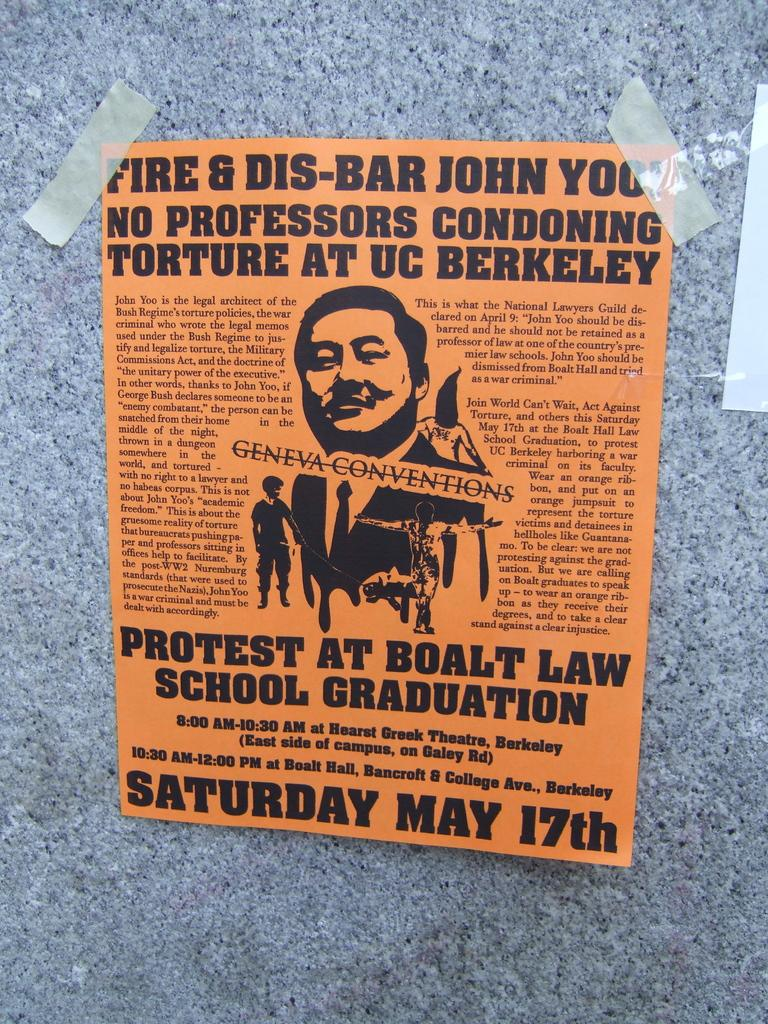What is attached to the wall in the image? There is a pamphlet in the image, and it is stuck on a wall. How many books are stacked on the lift in the image? There are no books or lifts present in the image; it only features a pamphlet stuck on a wall. 